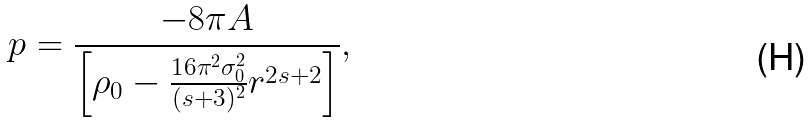<formula> <loc_0><loc_0><loc_500><loc_500>p = \frac { - 8 \pi A } { \left [ \rho _ { 0 } - \frac { 1 6 \pi ^ { 2 } \sigma _ { 0 } ^ { 2 } } { ( s + 3 ) ^ { 2 } } r ^ { 2 s + 2 } \right ] } ,</formula> 